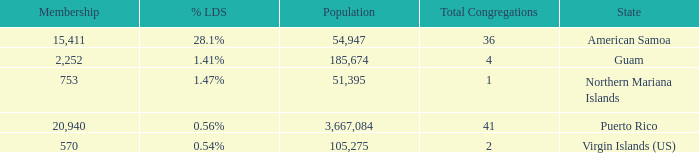What is Population, when Total Congregations is less than 4, and when % LDS is 0.54%? 105275.0. Could you parse the entire table? {'header': ['Membership', '% LDS', 'Population', 'Total Congregations', 'State'], 'rows': [['15,411', '28.1%', '54,947', '36', 'American Samoa'], ['2,252', '1.41%', '185,674', '4', 'Guam'], ['753', '1.47%', '51,395', '1', 'Northern Mariana Islands'], ['20,940', '0.56%', '3,667,084', '41', 'Puerto Rico'], ['570', '0.54%', '105,275', '2', 'Virgin Islands (US)']]} 